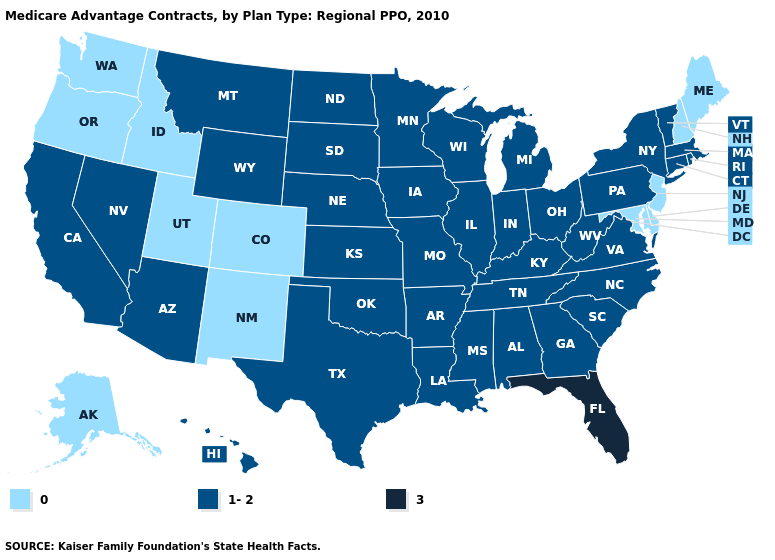What is the value of Ohio?
Write a very short answer. 1-2. Is the legend a continuous bar?
Answer briefly. No. What is the value of Hawaii?
Short answer required. 1-2. What is the value of Washington?
Short answer required. 0. What is the value of West Virginia?
Concise answer only. 1-2. What is the lowest value in states that border Maryland?
Keep it brief. 0. Does Arkansas have a lower value than Montana?
Concise answer only. No. What is the value of South Dakota?
Write a very short answer. 1-2. What is the value of Minnesota?
Answer briefly. 1-2. Name the states that have a value in the range 3?
Short answer required. Florida. Which states have the lowest value in the USA?
Be succinct. Alaska, Colorado, Delaware, Idaho, Maryland, Maine, New Hampshire, New Jersey, New Mexico, Oregon, Utah, Washington. Does Arkansas have the same value as New Mexico?
Keep it brief. No. What is the lowest value in the Northeast?
Be succinct. 0. 